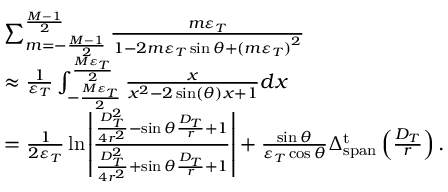Convert formula to latex. <formula><loc_0><loc_0><loc_500><loc_500>\begin{array} { r l } & { \sum _ { m = - \frac { M - 1 } { 2 } } ^ { \frac { M - 1 } { 2 } } { \frac { { m { \varepsilon _ { T } } } } { { 1 - 2 m { \varepsilon _ { T } } \sin \theta + { { ( m { \varepsilon _ { T } } ) } ^ { 2 } } } } } } \\ & { \approx \frac { 1 } { { { \varepsilon _ { T } } } } \int _ { - \frac { { M { \varepsilon _ { T } } } } { 2 } } ^ { \frac { { M { \varepsilon _ { T } } } } { 2 } } { \frac { x } { { { x ^ { 2 } } - 2 \sin ( \theta ) x + 1 } } } d x } \\ & { = \frac { 1 } { { 2 { \varepsilon _ { T } } } } \ln \left | { \frac { { \frac { { D _ { T } ^ { 2 } } } { { 4 { r ^ { 2 } } } } - \sin \theta \frac { { { D _ { T } } } } { r } + 1 } } { { \frac { { D _ { T } ^ { 2 } } } { { 4 { r ^ { 2 } } } } + \sin \theta \frac { { { D _ { T } } } } { r } + 1 } } } \right | + \frac { \sin \theta } { { { \varepsilon _ { T } } \cos \theta } } \Delta _ { s p a n } ^ { t } \left ( \frac { { { D _ { T } } } } { r } \right ) . } \end{array}</formula> 